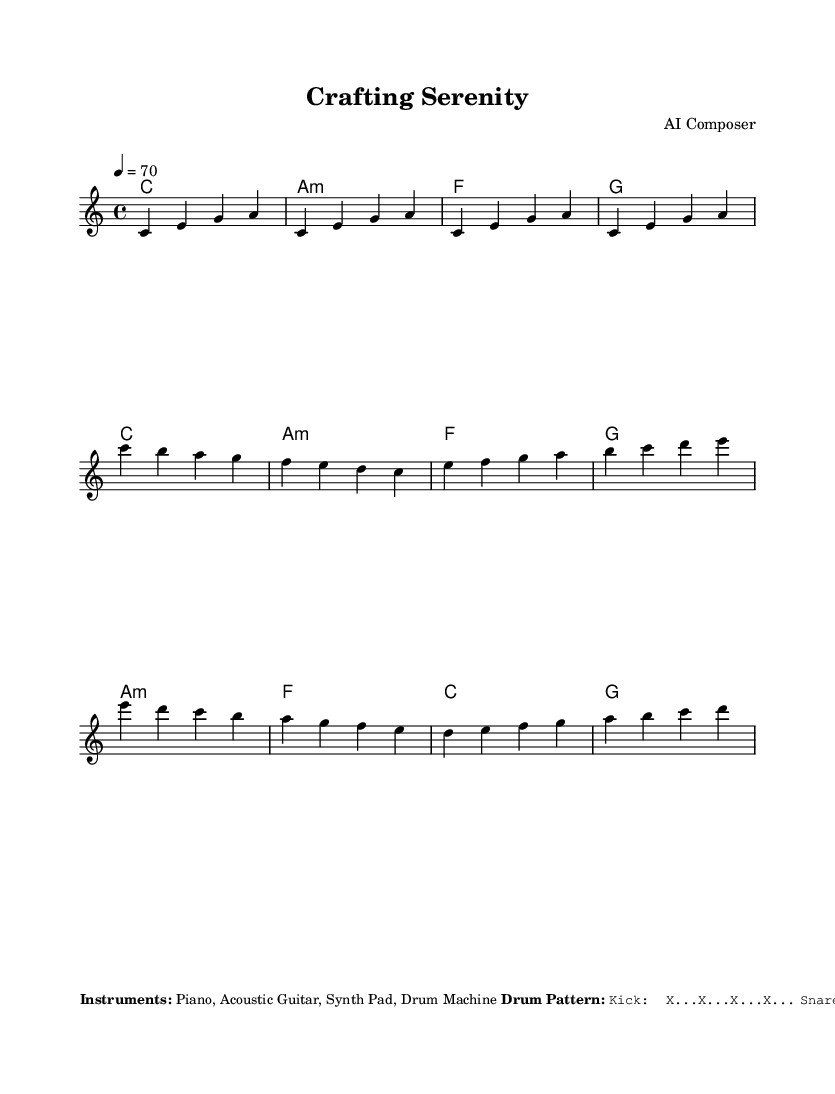What is the key signature of this music? The key signature is C major, which has no sharps or flats.
Answer: C major What is the time signature of this piece? The time signature shown in the music is 4/4, which means there are four beats per measure.
Answer: 4/4 What is the tempo marking for this piece? The tempo marking indicates a speed of 70 beats per minute for the piece.
Answer: 70 What instruments are featured in this composition? The sheet music mentions four instruments, which are listed as Piano, Acoustic Guitar, Synth Pad, and Drum Machine.
Answer: Piano, Acoustic Guitar, Synth Pad, Drum Machine How many chords are there in the verse section? The verse consists of four chords, which are played for each bar indicated in that section.
Answer: Four What are the two main sections of this piece called? The two main sections of the piece are labeled as the Verse and the Chorus, as indicated in the structure of the music.
Answer: Verse and Chorus What is the bassline in this piece? The bassline is specified in the sheet music and consists of the notes C2, A1, F2, and G2 played sequentially.
Answer: C2 A1 F2 G2 